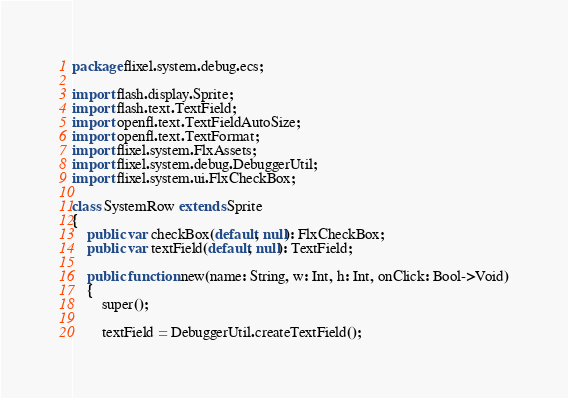Convert code to text. <code><loc_0><loc_0><loc_500><loc_500><_Haxe_>package flixel.system.debug.ecs;

import flash.display.Sprite;
import flash.text.TextField;
import openfl.text.TextFieldAutoSize;
import openfl.text.TextFormat;
import flixel.system.FlxAssets;
import flixel.system.debug.DebuggerUtil;
import flixel.system.ui.FlxCheckBox;

class SystemRow extends Sprite
{
	public var checkBox(default, null): FlxCheckBox;
	public var textField(default, null): TextField;

	public function new(name: String, w: Int, h: Int, onClick: Bool->Void)
	{
		super();

		textField = DebuggerUtil.createTextField();
</code> 